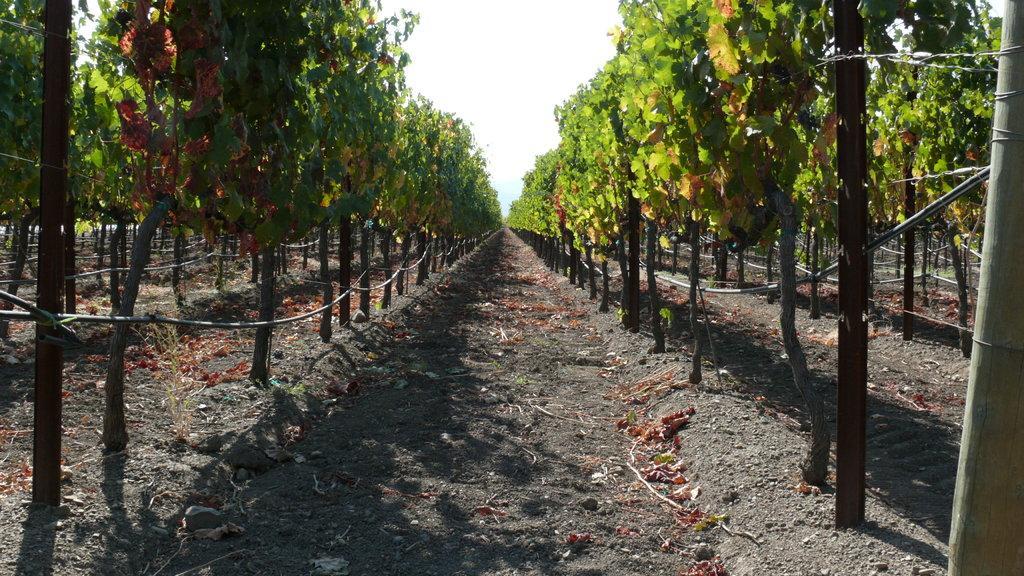How would you summarize this image in a sentence or two? At the left side and right side of the image there are trees. 